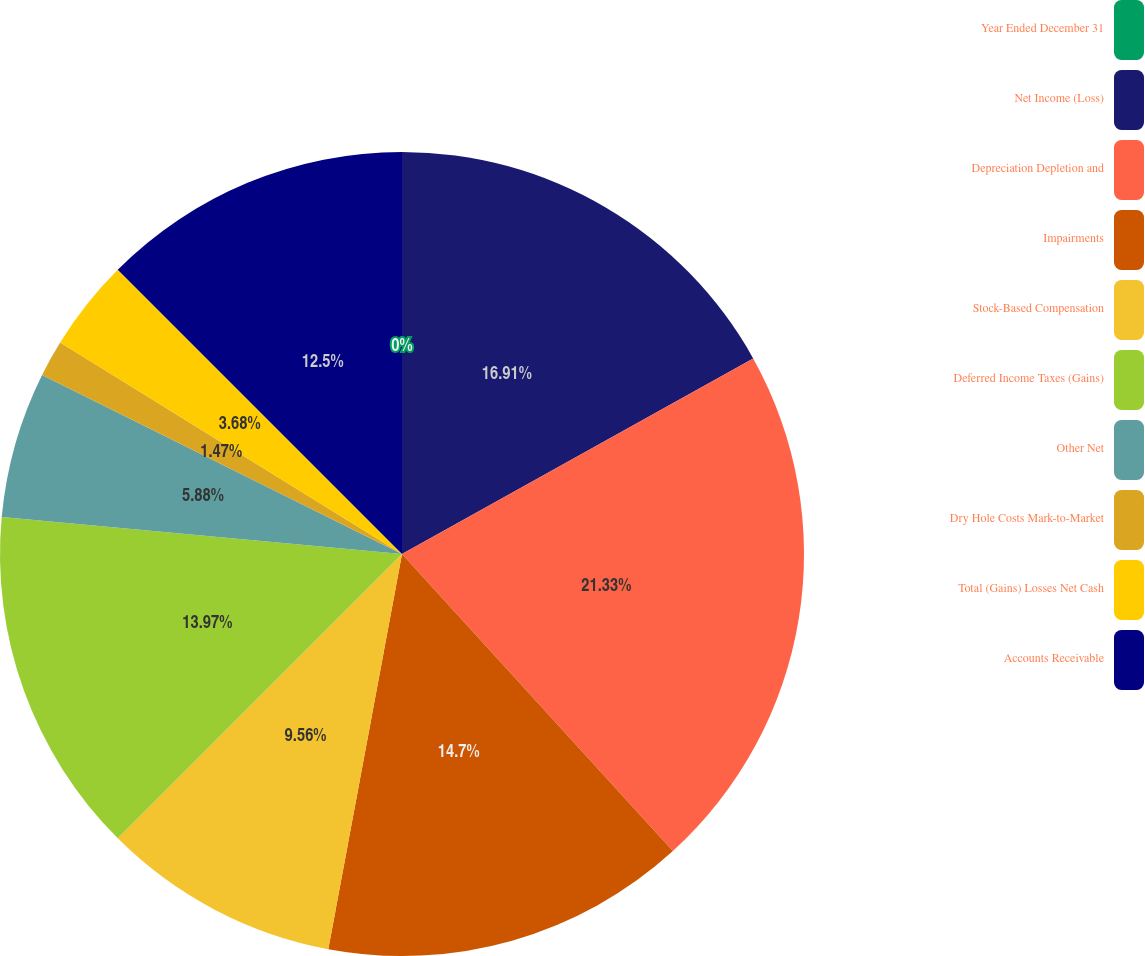Convert chart to OTSL. <chart><loc_0><loc_0><loc_500><loc_500><pie_chart><fcel>Year Ended December 31<fcel>Net Income (Loss)<fcel>Depreciation Depletion and<fcel>Impairments<fcel>Stock-Based Compensation<fcel>Deferred Income Taxes (Gains)<fcel>Other Net<fcel>Dry Hole Costs Mark-to-Market<fcel>Total (Gains) Losses Net Cash<fcel>Accounts Receivable<nl><fcel>0.0%<fcel>16.91%<fcel>21.32%<fcel>14.7%<fcel>9.56%<fcel>13.97%<fcel>5.88%<fcel>1.47%<fcel>3.68%<fcel>12.5%<nl></chart> 